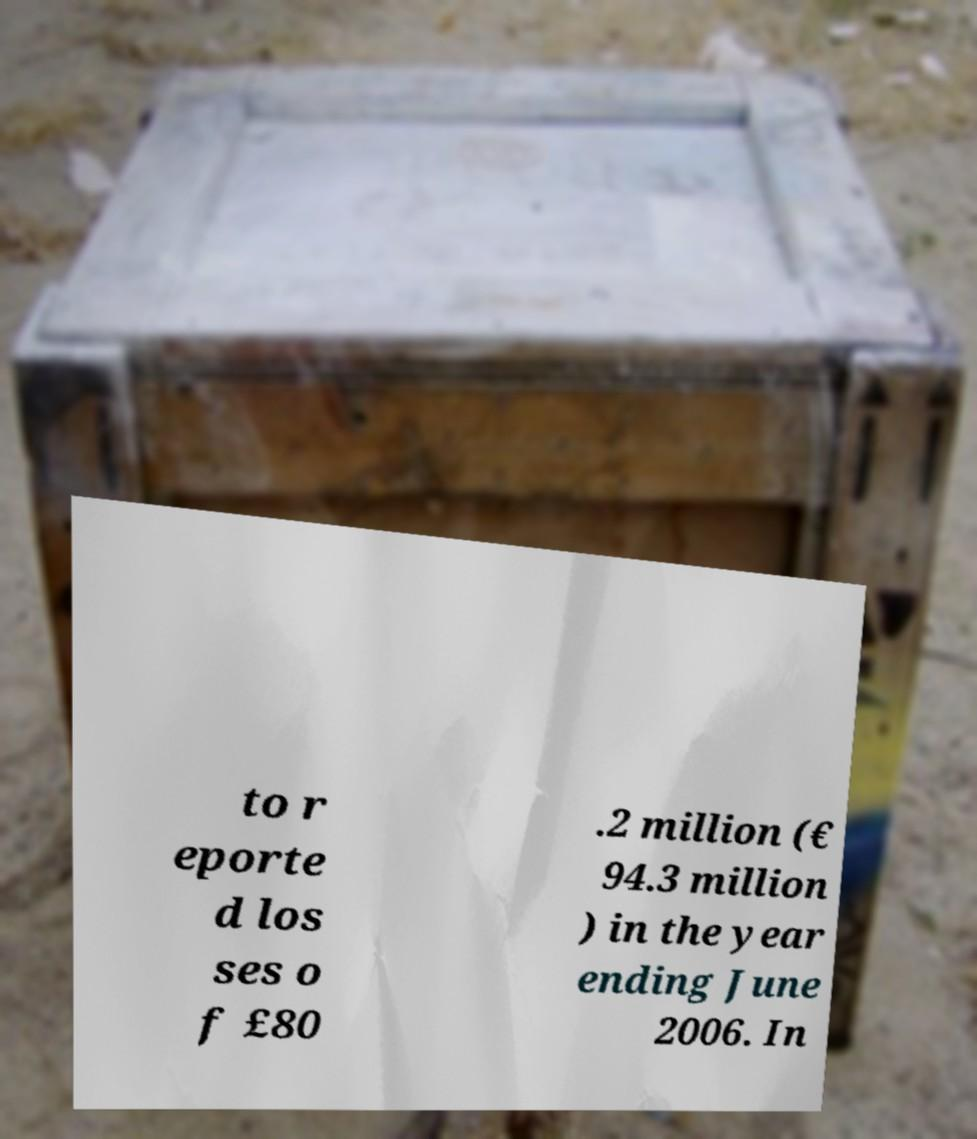Please identify and transcribe the text found in this image. to r eporte d los ses o f £80 .2 million (€ 94.3 million ) in the year ending June 2006. In 